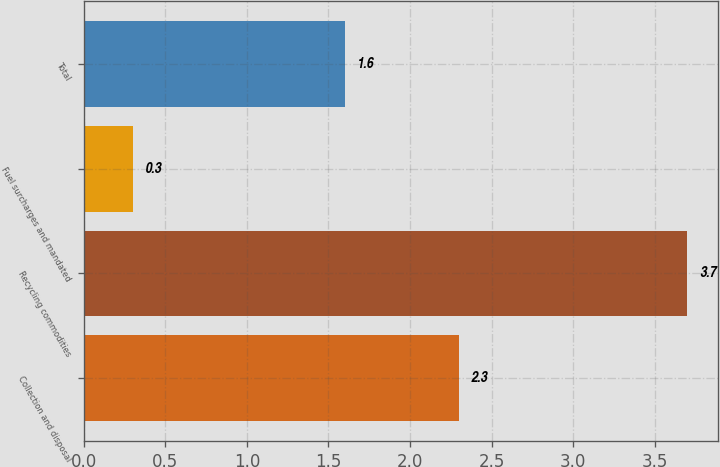<chart> <loc_0><loc_0><loc_500><loc_500><bar_chart><fcel>Collection and disposal<fcel>Recycling commodities<fcel>Fuel surcharges and mandated<fcel>Total<nl><fcel>2.3<fcel>3.7<fcel>0.3<fcel>1.6<nl></chart> 